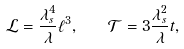<formula> <loc_0><loc_0><loc_500><loc_500>\mathcal { L } = \frac { \lambda _ { s } ^ { 4 } } { \lambda } \ell ^ { 3 } , \quad \mathcal { T } = 3 \frac { \lambda _ { s } ^ { 2 } } { \lambda } t ,</formula> 